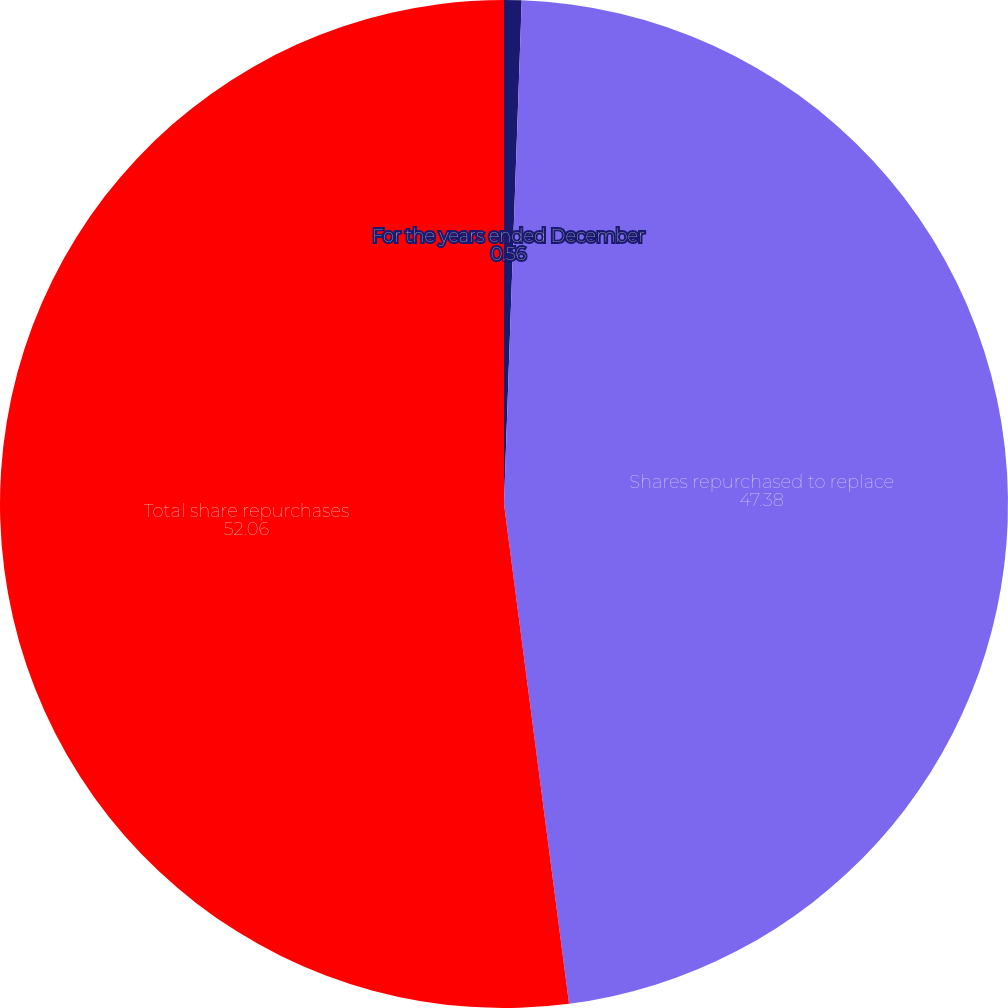Convert chart. <chart><loc_0><loc_0><loc_500><loc_500><pie_chart><fcel>For the years ended December<fcel>Shares repurchased to replace<fcel>Total share repurchases<nl><fcel>0.56%<fcel>47.38%<fcel>52.06%<nl></chart> 